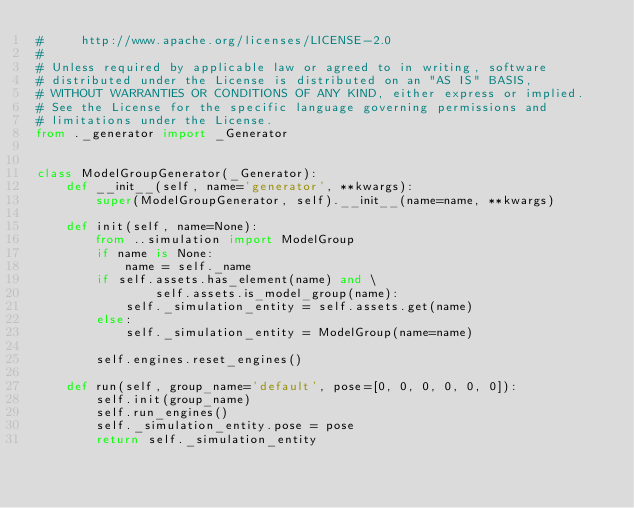Convert code to text. <code><loc_0><loc_0><loc_500><loc_500><_Python_>#     http://www.apache.org/licenses/LICENSE-2.0
#
# Unless required by applicable law or agreed to in writing, software
# distributed under the License is distributed on an "AS IS" BASIS,
# WITHOUT WARRANTIES OR CONDITIONS OF ANY KIND, either express or implied.
# See the License for the specific language governing permissions and
# limitations under the License.
from ._generator import _Generator


class ModelGroupGenerator(_Generator):
    def __init__(self, name='generator', **kwargs):
        super(ModelGroupGenerator, self).__init__(name=name, **kwargs)

    def init(self, name=None):
        from ..simulation import ModelGroup
        if name is None:
            name = self._name
        if self.assets.has_element(name) and \
                self.assets.is_model_group(name):
            self._simulation_entity = self.assets.get(name)
        else:
            self._simulation_entity = ModelGroup(name=name)

        self.engines.reset_engines()

    def run(self, group_name='default', pose=[0, 0, 0, 0, 0, 0]):
        self.init(group_name)
        self.run_engines()
        self._simulation_entity.pose = pose
        return self._simulation_entity
</code> 